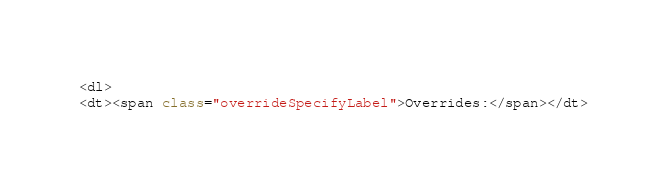Convert code to text. <code><loc_0><loc_0><loc_500><loc_500><_HTML_><dl>
<dt><span class="overrideSpecifyLabel">Overrides:</span></dt></code> 